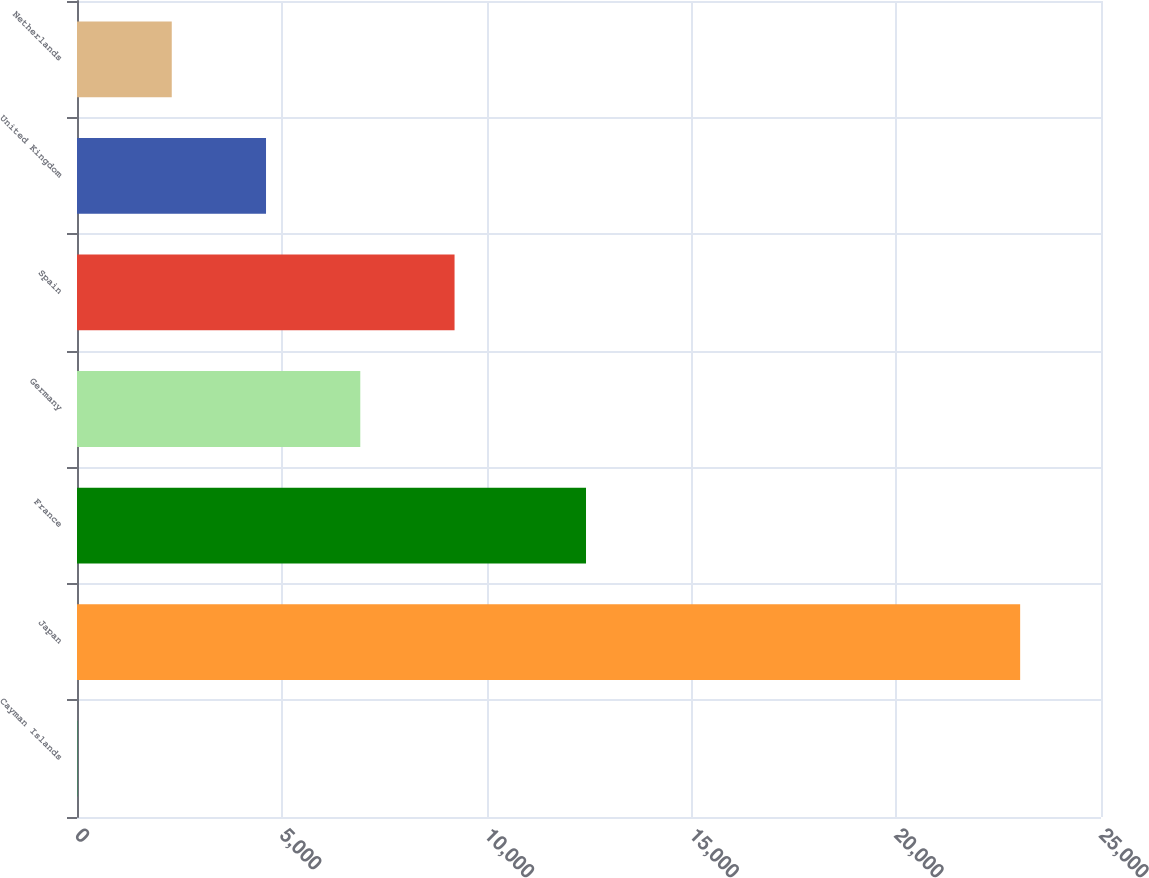<chart> <loc_0><loc_0><loc_500><loc_500><bar_chart><fcel>Cayman Islands<fcel>Japan<fcel>France<fcel>Germany<fcel>Spain<fcel>United Kingdom<fcel>Netherlands<nl><fcel>12<fcel>23026<fcel>12427<fcel>6916.2<fcel>9217.6<fcel>4614.8<fcel>2313.4<nl></chart> 